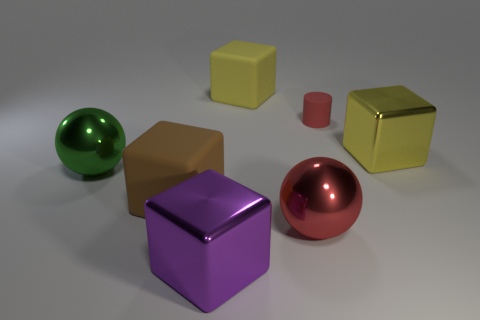Can you tell me about the lighting and shadows in the image? The image has a soft, diffuse lighting that creates gentle shadows on the ground beneath each object, suggesting an indirect light source. What does the presence of multiple geometric shapes suggest about the purpose of this image? The variety of geometric shapes may imply that this image is used for educational purposes to teach or demonstrate the concept of three-dimensional figures and their properties. 